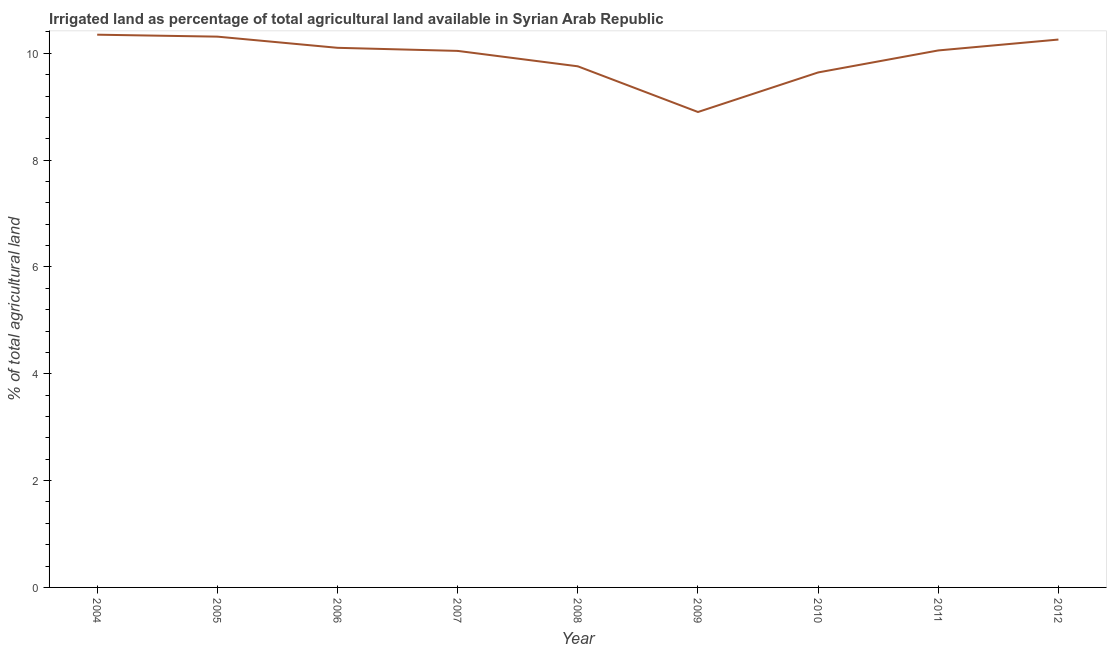What is the percentage of agricultural irrigated land in 2009?
Your answer should be compact. 8.9. Across all years, what is the maximum percentage of agricultural irrigated land?
Offer a very short reply. 10.35. Across all years, what is the minimum percentage of agricultural irrigated land?
Make the answer very short. 8.9. What is the sum of the percentage of agricultural irrigated land?
Your answer should be very brief. 89.42. What is the difference between the percentage of agricultural irrigated land in 2008 and 2010?
Offer a terse response. 0.11. What is the average percentage of agricultural irrigated land per year?
Offer a terse response. 9.94. What is the median percentage of agricultural irrigated land?
Your answer should be very brief. 10.05. What is the ratio of the percentage of agricultural irrigated land in 2005 to that in 2008?
Provide a short and direct response. 1.06. Is the difference between the percentage of agricultural irrigated land in 2004 and 2008 greater than the difference between any two years?
Offer a terse response. No. What is the difference between the highest and the second highest percentage of agricultural irrigated land?
Offer a terse response. 0.04. Is the sum of the percentage of agricultural irrigated land in 2008 and 2009 greater than the maximum percentage of agricultural irrigated land across all years?
Your answer should be very brief. Yes. What is the difference between the highest and the lowest percentage of agricultural irrigated land?
Make the answer very short. 1.45. Does the percentage of agricultural irrigated land monotonically increase over the years?
Your response must be concise. No. How many lines are there?
Give a very brief answer. 1. What is the difference between two consecutive major ticks on the Y-axis?
Your response must be concise. 2. What is the title of the graph?
Offer a very short reply. Irrigated land as percentage of total agricultural land available in Syrian Arab Republic. What is the label or title of the X-axis?
Provide a short and direct response. Year. What is the label or title of the Y-axis?
Your answer should be very brief. % of total agricultural land. What is the % of total agricultural land of 2004?
Provide a succinct answer. 10.35. What is the % of total agricultural land in 2005?
Your response must be concise. 10.31. What is the % of total agricultural land of 2006?
Your answer should be very brief. 10.1. What is the % of total agricultural land in 2007?
Your response must be concise. 10.05. What is the % of total agricultural land in 2008?
Make the answer very short. 9.76. What is the % of total agricultural land in 2009?
Your answer should be very brief. 8.9. What is the % of total agricultural land of 2010?
Make the answer very short. 9.64. What is the % of total agricultural land in 2011?
Your answer should be compact. 10.05. What is the % of total agricultural land of 2012?
Ensure brevity in your answer.  10.26. What is the difference between the % of total agricultural land in 2004 and 2005?
Your answer should be compact. 0.04. What is the difference between the % of total agricultural land in 2004 and 2006?
Keep it short and to the point. 0.25. What is the difference between the % of total agricultural land in 2004 and 2007?
Offer a terse response. 0.3. What is the difference between the % of total agricultural land in 2004 and 2008?
Provide a short and direct response. 0.59. What is the difference between the % of total agricultural land in 2004 and 2009?
Your answer should be very brief. 1.45. What is the difference between the % of total agricultural land in 2004 and 2010?
Give a very brief answer. 0.71. What is the difference between the % of total agricultural land in 2004 and 2011?
Provide a succinct answer. 0.29. What is the difference between the % of total agricultural land in 2004 and 2012?
Provide a short and direct response. 0.09. What is the difference between the % of total agricultural land in 2005 and 2006?
Your answer should be very brief. 0.21. What is the difference between the % of total agricultural land in 2005 and 2007?
Provide a short and direct response. 0.27. What is the difference between the % of total agricultural land in 2005 and 2008?
Offer a terse response. 0.56. What is the difference between the % of total agricultural land in 2005 and 2009?
Offer a terse response. 1.41. What is the difference between the % of total agricultural land in 2005 and 2010?
Keep it short and to the point. 0.67. What is the difference between the % of total agricultural land in 2005 and 2011?
Give a very brief answer. 0.26. What is the difference between the % of total agricultural land in 2005 and 2012?
Offer a very short reply. 0.05. What is the difference between the % of total agricultural land in 2006 and 2007?
Offer a terse response. 0.06. What is the difference between the % of total agricultural land in 2006 and 2008?
Offer a very short reply. 0.35. What is the difference between the % of total agricultural land in 2006 and 2009?
Make the answer very short. 1.2. What is the difference between the % of total agricultural land in 2006 and 2010?
Make the answer very short. 0.46. What is the difference between the % of total agricultural land in 2006 and 2011?
Ensure brevity in your answer.  0.05. What is the difference between the % of total agricultural land in 2006 and 2012?
Keep it short and to the point. -0.15. What is the difference between the % of total agricultural land in 2007 and 2008?
Make the answer very short. 0.29. What is the difference between the % of total agricultural land in 2007 and 2009?
Offer a very short reply. 1.14. What is the difference between the % of total agricultural land in 2007 and 2010?
Offer a very short reply. 0.4. What is the difference between the % of total agricultural land in 2007 and 2011?
Your response must be concise. -0.01. What is the difference between the % of total agricultural land in 2007 and 2012?
Keep it short and to the point. -0.21. What is the difference between the % of total agricultural land in 2008 and 2009?
Offer a terse response. 0.86. What is the difference between the % of total agricultural land in 2008 and 2010?
Your answer should be very brief. 0.11. What is the difference between the % of total agricultural land in 2008 and 2011?
Ensure brevity in your answer.  -0.3. What is the difference between the % of total agricultural land in 2008 and 2012?
Your response must be concise. -0.5. What is the difference between the % of total agricultural land in 2009 and 2010?
Your answer should be very brief. -0.74. What is the difference between the % of total agricultural land in 2009 and 2011?
Your response must be concise. -1.15. What is the difference between the % of total agricultural land in 2009 and 2012?
Offer a very short reply. -1.36. What is the difference between the % of total agricultural land in 2010 and 2011?
Give a very brief answer. -0.41. What is the difference between the % of total agricultural land in 2010 and 2012?
Your answer should be compact. -0.62. What is the difference between the % of total agricultural land in 2011 and 2012?
Provide a succinct answer. -0.2. What is the ratio of the % of total agricultural land in 2004 to that in 2008?
Give a very brief answer. 1.06. What is the ratio of the % of total agricultural land in 2004 to that in 2009?
Make the answer very short. 1.16. What is the ratio of the % of total agricultural land in 2004 to that in 2010?
Offer a very short reply. 1.07. What is the ratio of the % of total agricultural land in 2004 to that in 2011?
Provide a short and direct response. 1.03. What is the ratio of the % of total agricultural land in 2005 to that in 2008?
Your answer should be compact. 1.06. What is the ratio of the % of total agricultural land in 2005 to that in 2009?
Provide a succinct answer. 1.16. What is the ratio of the % of total agricultural land in 2005 to that in 2010?
Make the answer very short. 1.07. What is the ratio of the % of total agricultural land in 2005 to that in 2012?
Keep it short and to the point. 1. What is the ratio of the % of total agricultural land in 2006 to that in 2008?
Provide a succinct answer. 1.03. What is the ratio of the % of total agricultural land in 2006 to that in 2009?
Your response must be concise. 1.14. What is the ratio of the % of total agricultural land in 2006 to that in 2010?
Your answer should be very brief. 1.05. What is the ratio of the % of total agricultural land in 2006 to that in 2012?
Your answer should be compact. 0.98. What is the ratio of the % of total agricultural land in 2007 to that in 2009?
Ensure brevity in your answer.  1.13. What is the ratio of the % of total agricultural land in 2007 to that in 2010?
Your response must be concise. 1.04. What is the ratio of the % of total agricultural land in 2008 to that in 2009?
Provide a succinct answer. 1.1. What is the ratio of the % of total agricultural land in 2008 to that in 2011?
Make the answer very short. 0.97. What is the ratio of the % of total agricultural land in 2008 to that in 2012?
Your response must be concise. 0.95. What is the ratio of the % of total agricultural land in 2009 to that in 2010?
Offer a very short reply. 0.92. What is the ratio of the % of total agricultural land in 2009 to that in 2011?
Your answer should be very brief. 0.89. What is the ratio of the % of total agricultural land in 2009 to that in 2012?
Your answer should be very brief. 0.87. What is the ratio of the % of total agricultural land in 2010 to that in 2011?
Keep it short and to the point. 0.96. What is the ratio of the % of total agricultural land in 2011 to that in 2012?
Your answer should be very brief. 0.98. 